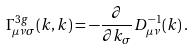<formula> <loc_0><loc_0><loc_500><loc_500>\Gamma _ { \mu \nu \sigma } ^ { 3 g } ( k , k ) = - \frac { \partial } { \partial k _ { \sigma } } D _ { \mu \nu } ^ { - 1 } ( k ) \, .</formula> 